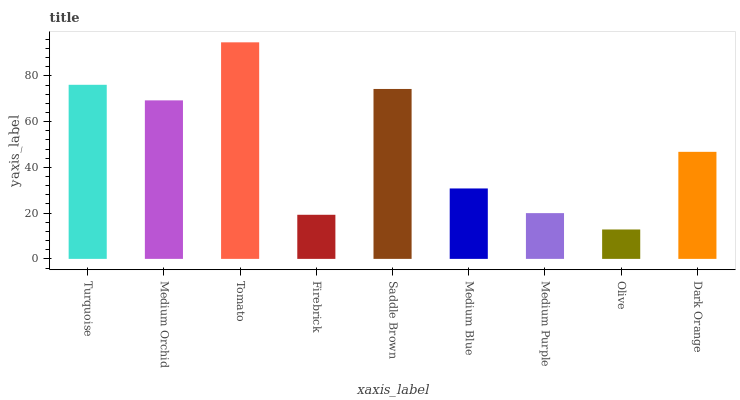Is Olive the minimum?
Answer yes or no. Yes. Is Tomato the maximum?
Answer yes or no. Yes. Is Medium Orchid the minimum?
Answer yes or no. No. Is Medium Orchid the maximum?
Answer yes or no. No. Is Turquoise greater than Medium Orchid?
Answer yes or no. Yes. Is Medium Orchid less than Turquoise?
Answer yes or no. Yes. Is Medium Orchid greater than Turquoise?
Answer yes or no. No. Is Turquoise less than Medium Orchid?
Answer yes or no. No. Is Dark Orange the high median?
Answer yes or no. Yes. Is Dark Orange the low median?
Answer yes or no. Yes. Is Saddle Brown the high median?
Answer yes or no. No. Is Saddle Brown the low median?
Answer yes or no. No. 